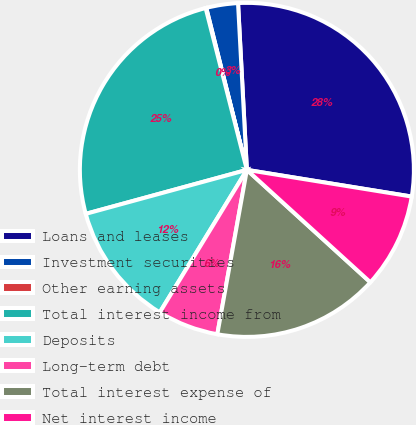<chart> <loc_0><loc_0><loc_500><loc_500><pie_chart><fcel>Loans and leases<fcel>Investment securities<fcel>Other earning assets<fcel>Total interest income from<fcel>Deposits<fcel>Long-term debt<fcel>Total interest expense of<fcel>Net interest income<nl><fcel>28.4%<fcel>3.07%<fcel>0.06%<fcel>25.27%<fcel>12.03%<fcel>5.9%<fcel>16.08%<fcel>9.2%<nl></chart> 